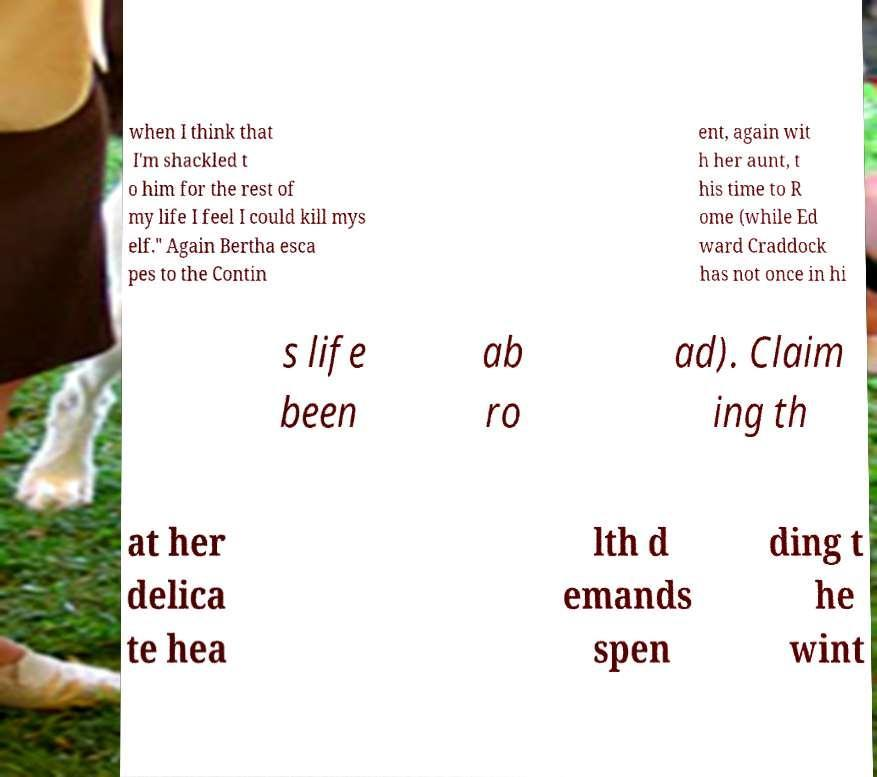There's text embedded in this image that I need extracted. Can you transcribe it verbatim? when I think that I'm shackled t o him for the rest of my life I feel I could kill mys elf." Again Bertha esca pes to the Contin ent, again wit h her aunt, t his time to R ome (while Ed ward Craddock has not once in hi s life been ab ro ad). Claim ing th at her delica te hea lth d emands spen ding t he wint 